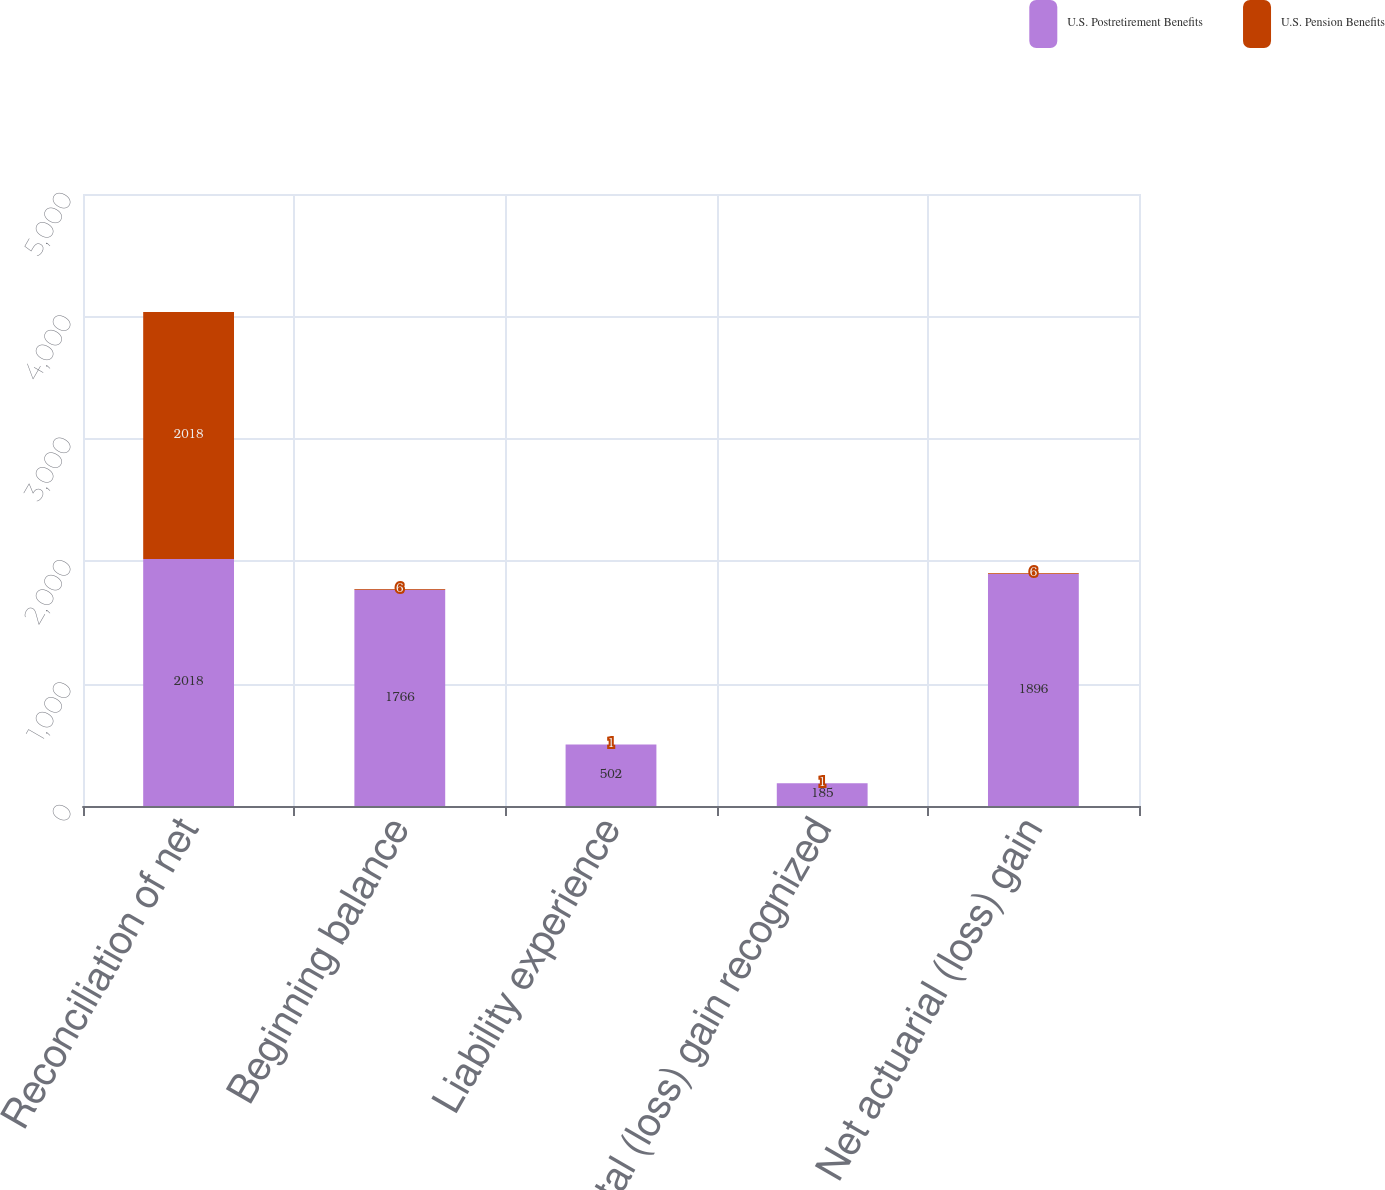Convert chart. <chart><loc_0><loc_0><loc_500><loc_500><stacked_bar_chart><ecel><fcel>Reconciliation of net<fcel>Beginning balance<fcel>Liability experience<fcel>Total (loss) gain recognized<fcel>Net actuarial (loss) gain<nl><fcel>U.S. Postretirement Benefits<fcel>2018<fcel>1766<fcel>502<fcel>185<fcel>1896<nl><fcel>U.S. Pension Benefits<fcel>2018<fcel>6<fcel>1<fcel>1<fcel>6<nl></chart> 